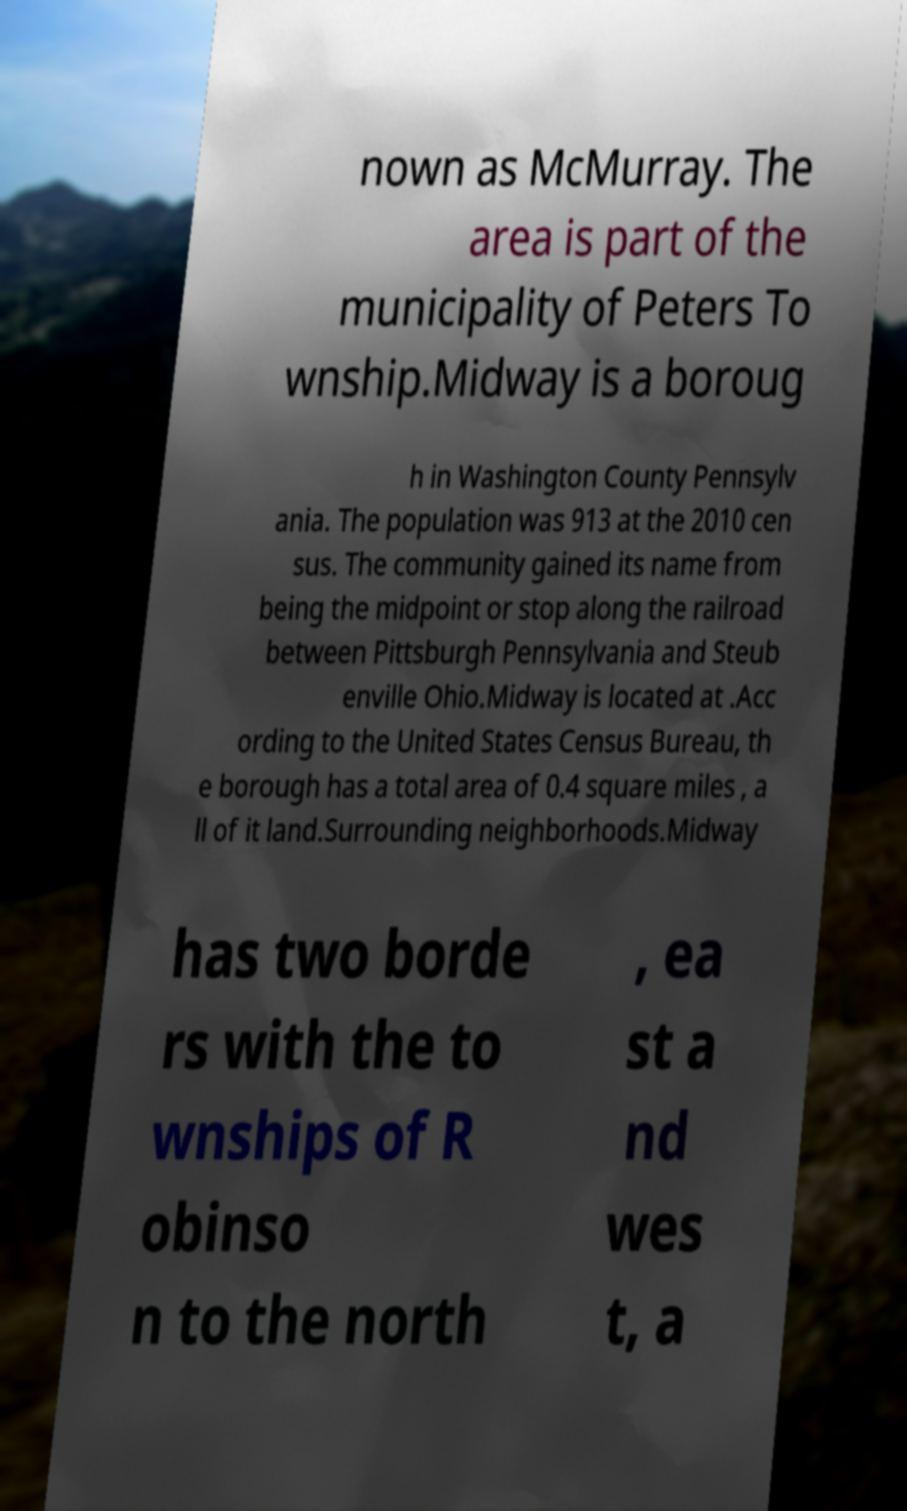I need the written content from this picture converted into text. Can you do that? nown as McMurray. The area is part of the municipality of Peters To wnship.Midway is a boroug h in Washington County Pennsylv ania. The population was 913 at the 2010 cen sus. The community gained its name from being the midpoint or stop along the railroad between Pittsburgh Pennsylvania and Steub enville Ohio.Midway is located at .Acc ording to the United States Census Bureau, th e borough has a total area of 0.4 square miles , a ll of it land.Surrounding neighborhoods.Midway has two borde rs with the to wnships of R obinso n to the north , ea st a nd wes t, a 